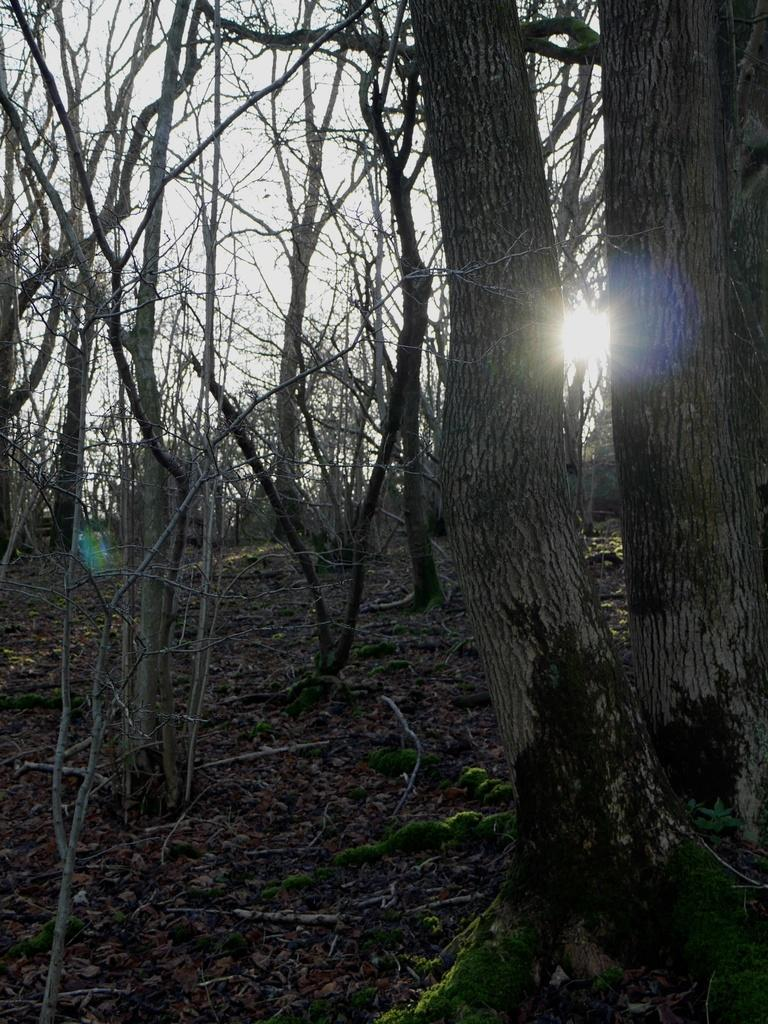What type of natural vegetation can be seen in the image? There are trees in the image. What is the condition of the sky in the image? The sky is cloudy in the image. Can you describe the lighting in the image? Sunlight is visible in the image. What type of comfort can be found in the image? There is no reference to comfort or any object that provides comfort in the image. 